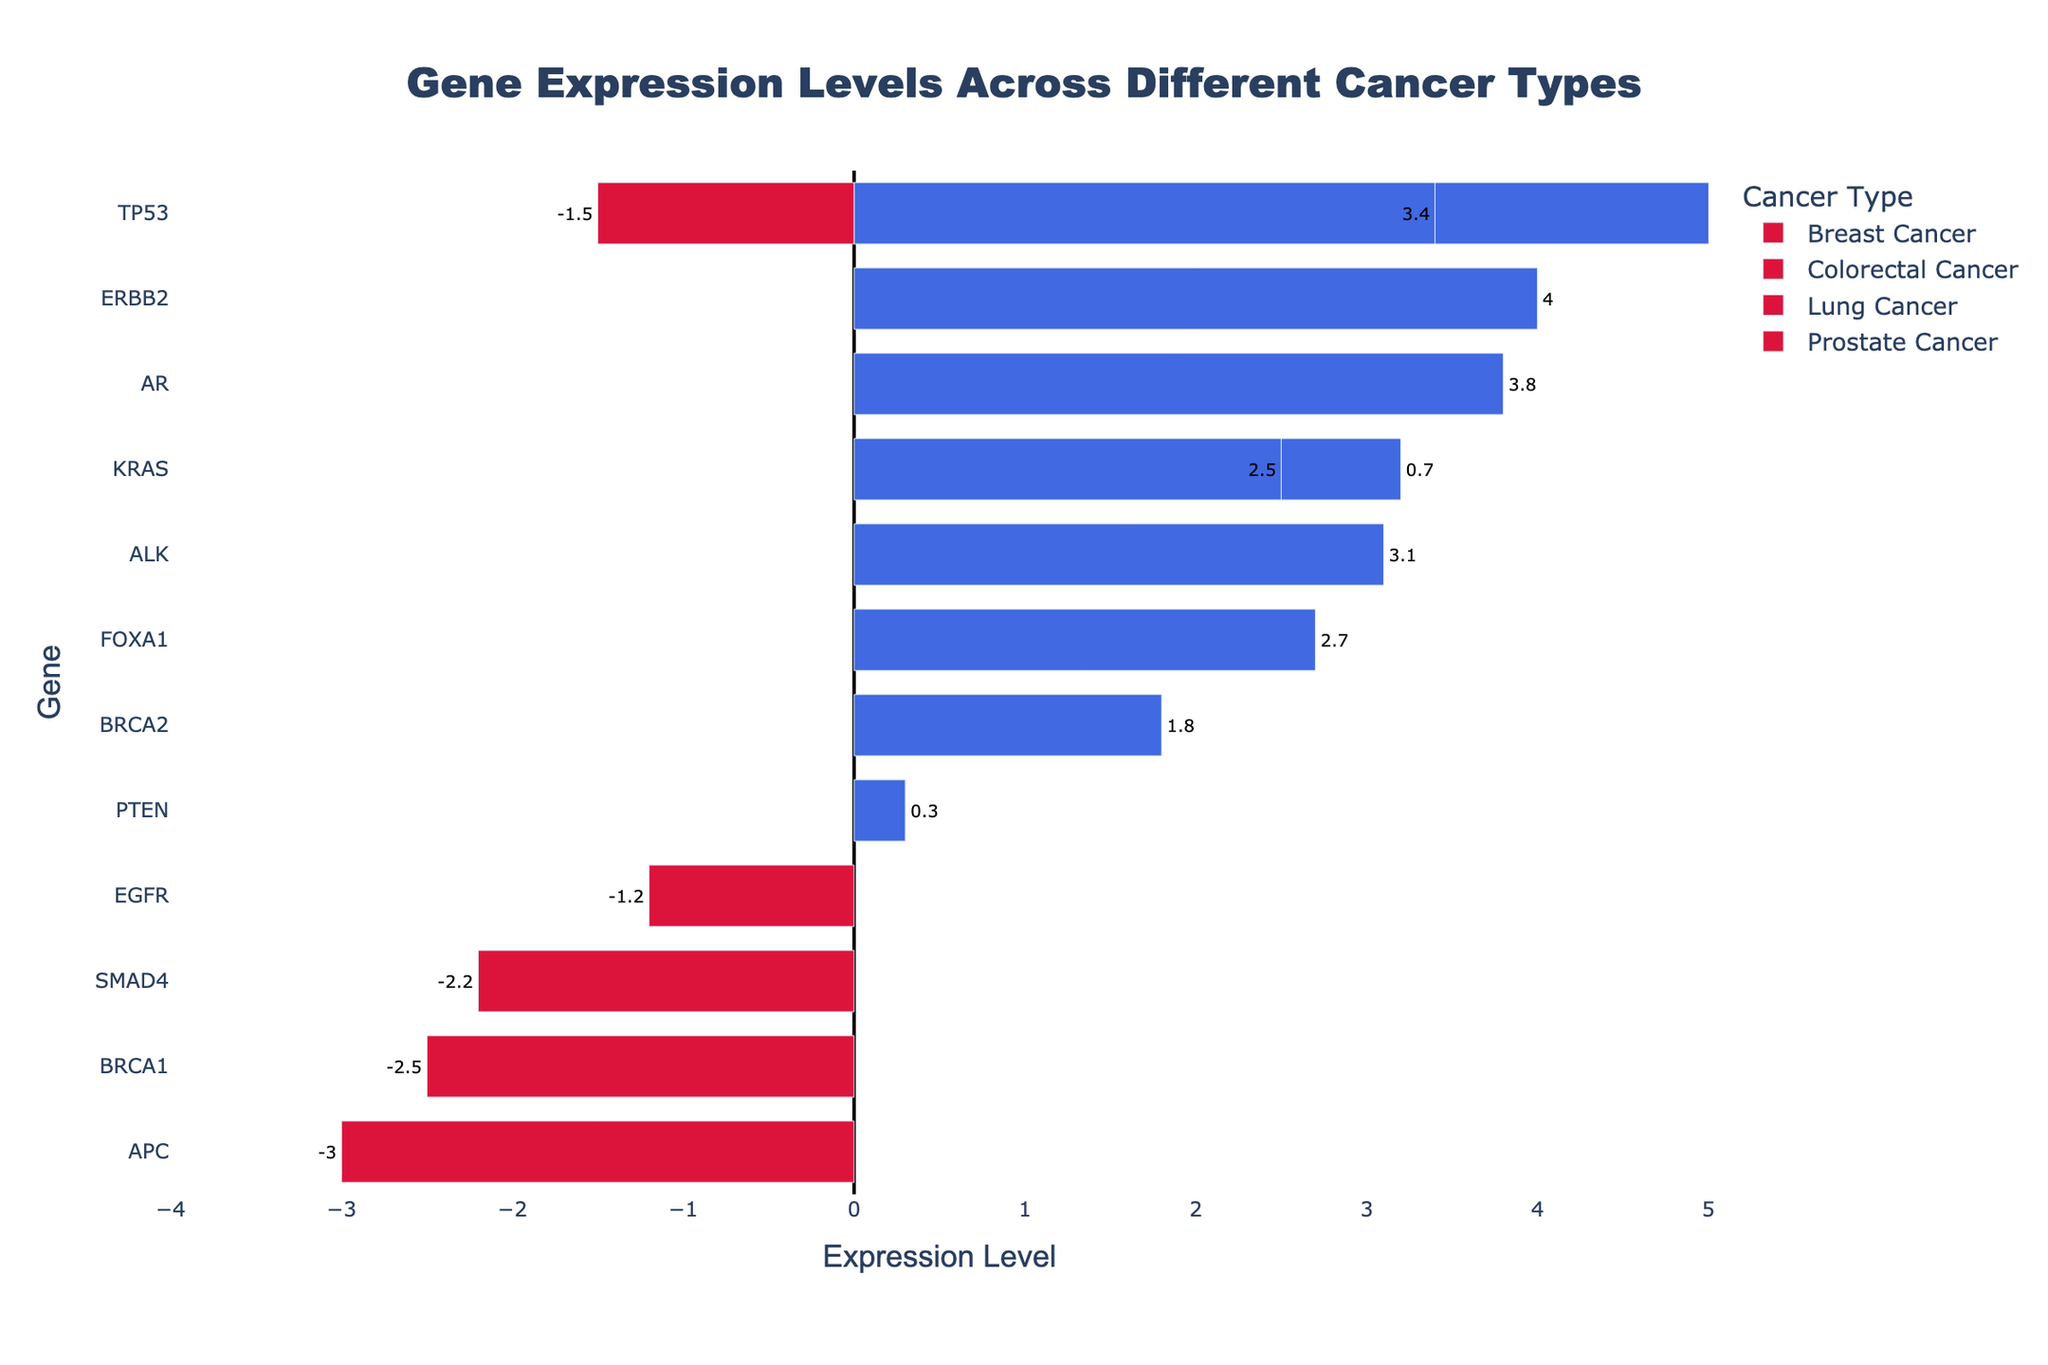Which cancer type has the highest gene expression level for TP53? To answer this, find the TP53 gene bar for each cancer type and compare their lengths. The highest bar represents the highest expression level.
Answer: Breast Cancer Which two genes in Breast Cancer have negative expression levels? Look at the Breast Cancer section and identify bars that extend to the left (negative) and note their genes.
Answer: BRCA1, BRCA2 How many genes in Colorectal Cancer have negative expression levels? In the Colorectal Cancer section, count the bars that extend to the left of the 0 line.
Answer: Two Compare the gene expression levels of KRAS in Lung Cancer and Colorectal Cancer. Which one is higher? Locate the KRAS bar in the Lung Cancer section and the KRAS bar in the Colorectal Cancer section, then compare their lengths to determine which is longer.
Answer: Colorectal Cancer What is the range of expression levels for genes in Prostate Cancer? Identify the maximum and minimum values of the bars in the Prostate Cancer section, and calculate the difference between these values.
Answer: 5.3 Which gene in Lung Cancer has the highest positive expression level? In the Lung Cancer section, find the bar with the longest extension to the right (positive) and its corresponding gene.
Answer: ALK How does the expression level of APC in Colorectal Cancer compare to the expression level of BRCA1 in Breast Cancer? Identify the bars of the APC gene in Colorectal Cancer and BRCA1 in Breast Cancer and compare their lengths and directions.
Answer: APC is lower Which cancer type has the largest range of expression levels for its genes? Calculate the range of expression levels for each cancer type and compare them to find the largest one.
Answer: Breast Cancer 